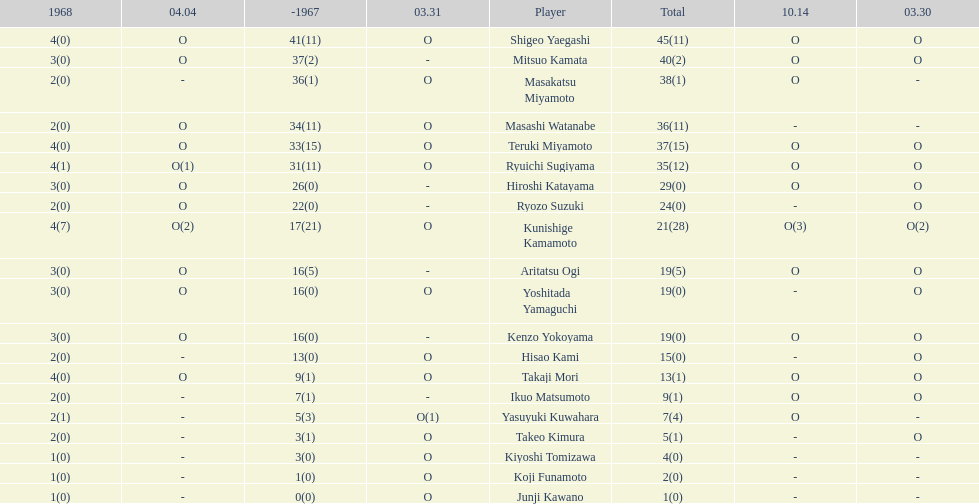Total appearances by masakatsu miyamoto? 38. 